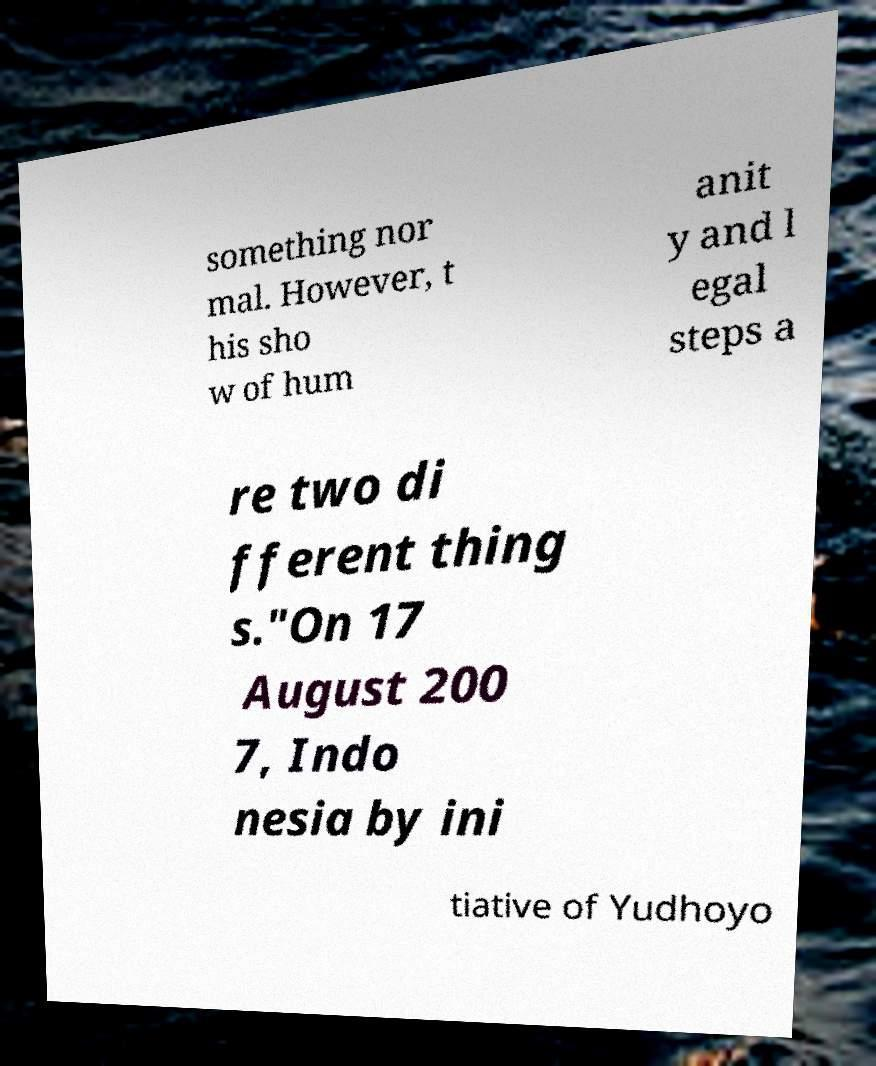I need the written content from this picture converted into text. Can you do that? something nor mal. However, t his sho w of hum anit y and l egal steps a re two di fferent thing s."On 17 August 200 7, Indo nesia by ini tiative of Yudhoyo 